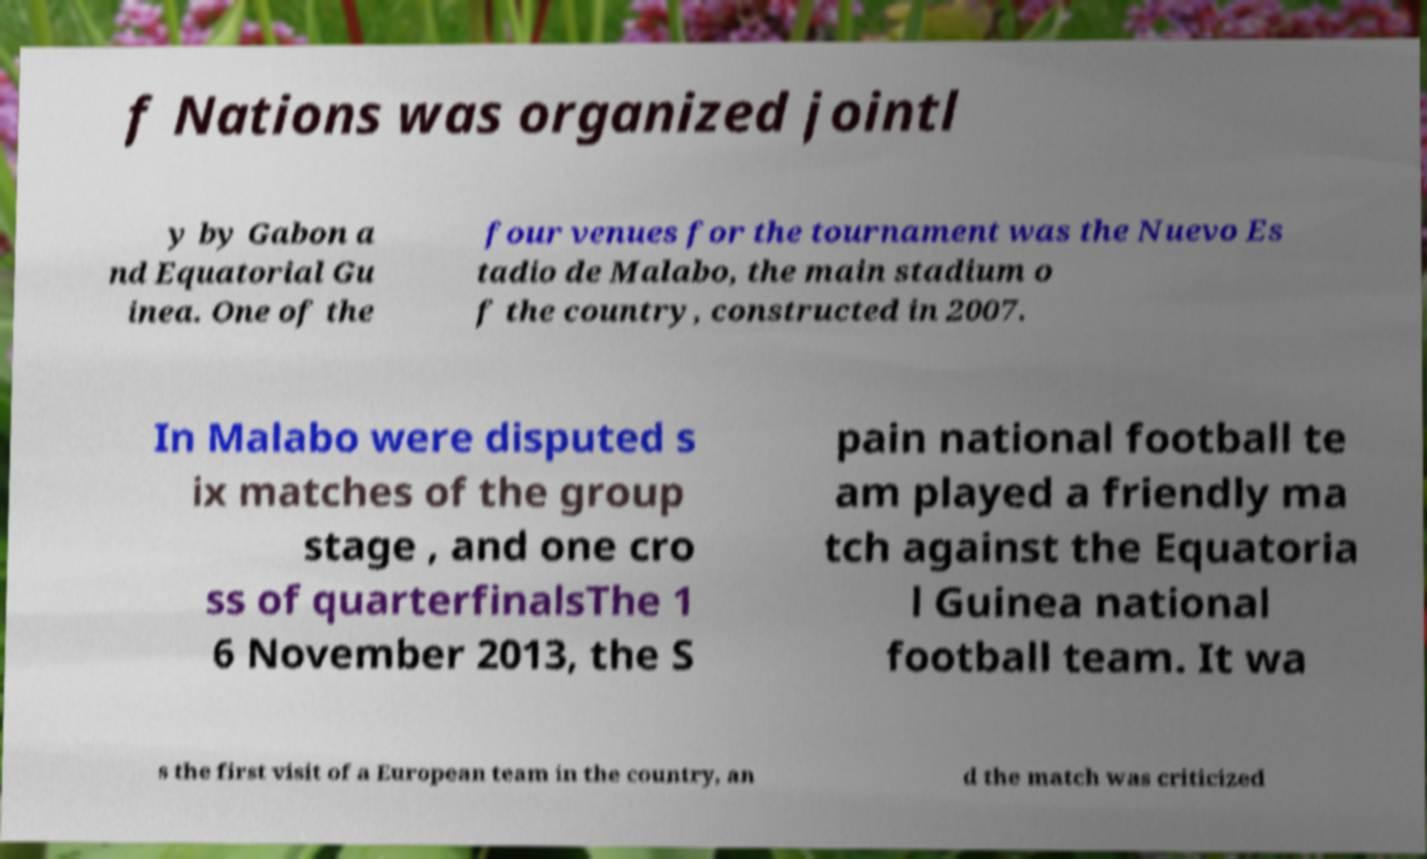Please identify and transcribe the text found in this image. f Nations was organized jointl y by Gabon a nd Equatorial Gu inea. One of the four venues for the tournament was the Nuevo Es tadio de Malabo, the main stadium o f the country, constructed in 2007. In Malabo were disputed s ix matches of the group stage , and one cro ss of quarterfinalsThe 1 6 November 2013, the S pain national football te am played a friendly ma tch against the Equatoria l Guinea national football team. It wa s the first visit of a European team in the country, an d the match was criticized 